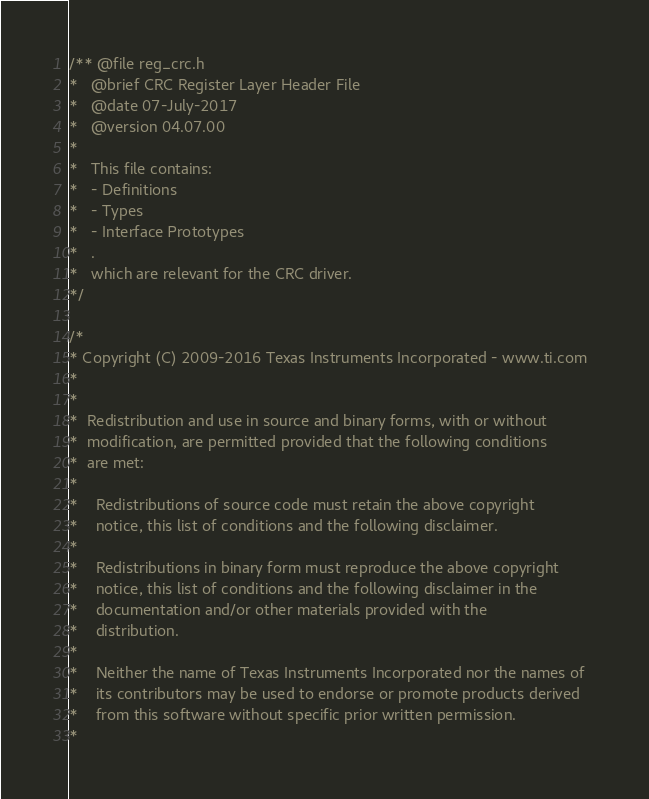Convert code to text. <code><loc_0><loc_0><loc_500><loc_500><_C_>/** @file reg_crc.h
*   @brief CRC Register Layer Header File
*   @date 07-July-2017
*   @version 04.07.00
*   
*   This file contains:
*   - Definitions
*   - Types
*   - Interface Prototypes
*   .
*   which are relevant for the CRC driver.
*/

/* 
* Copyright (C) 2009-2016 Texas Instruments Incorporated - www.ti.com  
* 
* 
*  Redistribution and use in source and binary forms, with or without 
*  modification, are permitted provided that the following conditions 
*  are met:
*
*    Redistributions of source code must retain the above copyright 
*    notice, this list of conditions and the following disclaimer.
*
*    Redistributions in binary form must reproduce the above copyright
*    notice, this list of conditions and the following disclaimer in the 
*    documentation and/or other materials provided with the   
*    distribution.
*
*    Neither the name of Texas Instruments Incorporated nor the names of
*    its contributors may be used to endorse or promote products derived
*    from this software without specific prior written permission.
*</code> 